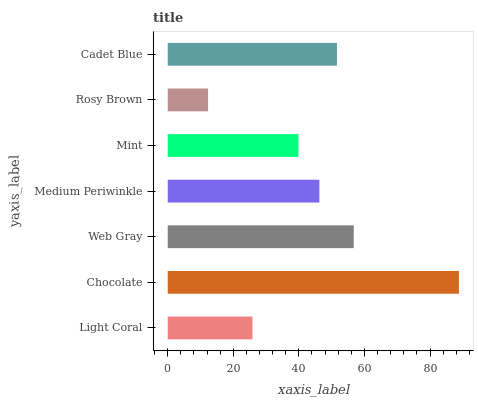Is Rosy Brown the minimum?
Answer yes or no. Yes. Is Chocolate the maximum?
Answer yes or no. Yes. Is Web Gray the minimum?
Answer yes or no. No. Is Web Gray the maximum?
Answer yes or no. No. Is Chocolate greater than Web Gray?
Answer yes or no. Yes. Is Web Gray less than Chocolate?
Answer yes or no. Yes. Is Web Gray greater than Chocolate?
Answer yes or no. No. Is Chocolate less than Web Gray?
Answer yes or no. No. Is Medium Periwinkle the high median?
Answer yes or no. Yes. Is Medium Periwinkle the low median?
Answer yes or no. Yes. Is Chocolate the high median?
Answer yes or no. No. Is Web Gray the low median?
Answer yes or no. No. 